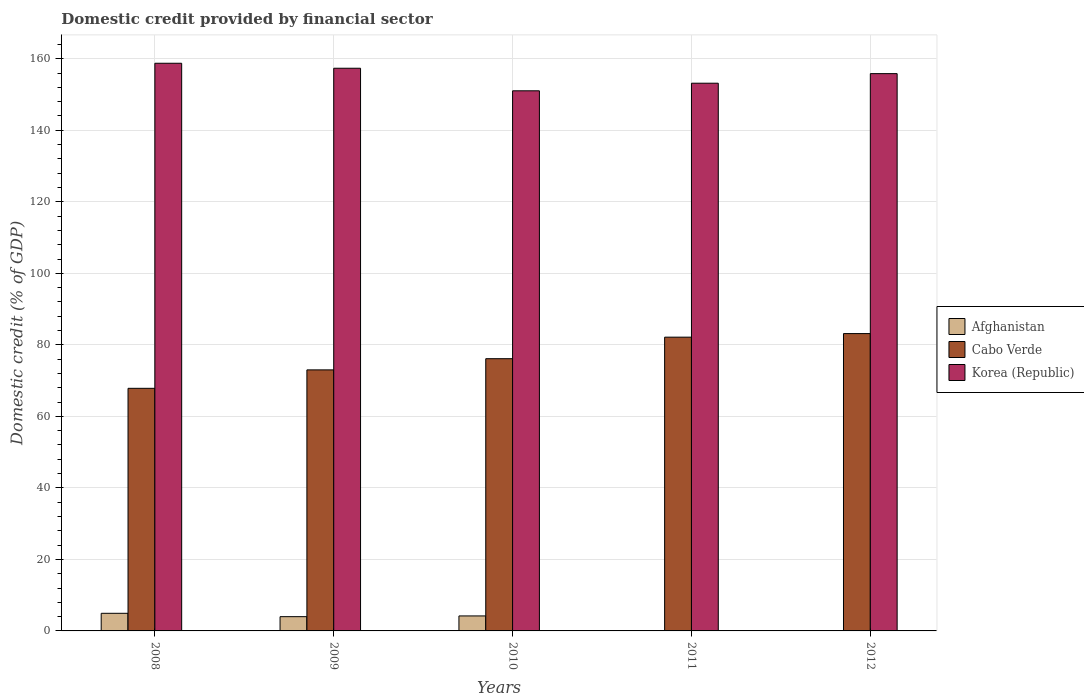How many different coloured bars are there?
Provide a succinct answer. 3. How many groups of bars are there?
Ensure brevity in your answer.  5. Are the number of bars on each tick of the X-axis equal?
Ensure brevity in your answer.  No. How many bars are there on the 3rd tick from the left?
Your response must be concise. 3. How many bars are there on the 5th tick from the right?
Give a very brief answer. 3. What is the label of the 4th group of bars from the left?
Give a very brief answer. 2011. In how many cases, is the number of bars for a given year not equal to the number of legend labels?
Keep it short and to the point. 2. What is the domestic credit in Cabo Verde in 2011?
Your answer should be very brief. 82.15. Across all years, what is the maximum domestic credit in Afghanistan?
Offer a terse response. 4.93. Across all years, what is the minimum domestic credit in Cabo Verde?
Offer a terse response. 67.84. In which year was the domestic credit in Cabo Verde maximum?
Provide a short and direct response. 2012. What is the total domestic credit in Afghanistan in the graph?
Make the answer very short. 13.11. What is the difference between the domestic credit in Afghanistan in 2009 and that in 2010?
Provide a short and direct response. -0.2. What is the difference between the domestic credit in Cabo Verde in 2011 and the domestic credit in Korea (Republic) in 2009?
Ensure brevity in your answer.  -75.2. What is the average domestic credit in Afghanistan per year?
Keep it short and to the point. 2.62. In the year 2010, what is the difference between the domestic credit in Cabo Verde and domestic credit in Korea (Republic)?
Provide a succinct answer. -74.91. What is the ratio of the domestic credit in Cabo Verde in 2009 to that in 2011?
Give a very brief answer. 0.89. Is the domestic credit in Cabo Verde in 2008 less than that in 2009?
Provide a short and direct response. Yes. What is the difference between the highest and the second highest domestic credit in Afghanistan?
Offer a very short reply. 0.73. What is the difference between the highest and the lowest domestic credit in Korea (Republic)?
Provide a succinct answer. 7.7. Are all the bars in the graph horizontal?
Make the answer very short. No. How many years are there in the graph?
Offer a very short reply. 5. Does the graph contain grids?
Offer a very short reply. Yes. How are the legend labels stacked?
Make the answer very short. Vertical. What is the title of the graph?
Provide a succinct answer. Domestic credit provided by financial sector. What is the label or title of the Y-axis?
Offer a terse response. Domestic credit (% of GDP). What is the Domestic credit (% of GDP) in Afghanistan in 2008?
Ensure brevity in your answer.  4.93. What is the Domestic credit (% of GDP) in Cabo Verde in 2008?
Your response must be concise. 67.84. What is the Domestic credit (% of GDP) of Korea (Republic) in 2008?
Provide a succinct answer. 158.75. What is the Domestic credit (% of GDP) of Afghanistan in 2009?
Provide a succinct answer. 3.99. What is the Domestic credit (% of GDP) of Cabo Verde in 2009?
Your answer should be very brief. 73. What is the Domestic credit (% of GDP) in Korea (Republic) in 2009?
Ensure brevity in your answer.  157.35. What is the Domestic credit (% of GDP) in Afghanistan in 2010?
Offer a very short reply. 4.19. What is the Domestic credit (% of GDP) of Cabo Verde in 2010?
Give a very brief answer. 76.13. What is the Domestic credit (% of GDP) in Korea (Republic) in 2010?
Your answer should be compact. 151.04. What is the Domestic credit (% of GDP) in Afghanistan in 2011?
Provide a short and direct response. 0. What is the Domestic credit (% of GDP) of Cabo Verde in 2011?
Provide a succinct answer. 82.15. What is the Domestic credit (% of GDP) of Korea (Republic) in 2011?
Keep it short and to the point. 153.17. What is the Domestic credit (% of GDP) of Afghanistan in 2012?
Provide a short and direct response. 0. What is the Domestic credit (% of GDP) of Cabo Verde in 2012?
Offer a terse response. 83.15. What is the Domestic credit (% of GDP) in Korea (Republic) in 2012?
Your response must be concise. 155.85. Across all years, what is the maximum Domestic credit (% of GDP) of Afghanistan?
Your answer should be very brief. 4.93. Across all years, what is the maximum Domestic credit (% of GDP) of Cabo Verde?
Offer a very short reply. 83.15. Across all years, what is the maximum Domestic credit (% of GDP) in Korea (Republic)?
Your answer should be compact. 158.75. Across all years, what is the minimum Domestic credit (% of GDP) of Cabo Verde?
Offer a very short reply. 67.84. Across all years, what is the minimum Domestic credit (% of GDP) of Korea (Republic)?
Your response must be concise. 151.04. What is the total Domestic credit (% of GDP) of Afghanistan in the graph?
Offer a very short reply. 13.11. What is the total Domestic credit (% of GDP) of Cabo Verde in the graph?
Provide a succinct answer. 382.27. What is the total Domestic credit (% of GDP) of Korea (Republic) in the graph?
Ensure brevity in your answer.  776.15. What is the difference between the Domestic credit (% of GDP) in Afghanistan in 2008 and that in 2009?
Give a very brief answer. 0.94. What is the difference between the Domestic credit (% of GDP) of Cabo Verde in 2008 and that in 2009?
Your response must be concise. -5.16. What is the difference between the Domestic credit (% of GDP) of Korea (Republic) in 2008 and that in 2009?
Your answer should be compact. 1.39. What is the difference between the Domestic credit (% of GDP) of Afghanistan in 2008 and that in 2010?
Offer a very short reply. 0.73. What is the difference between the Domestic credit (% of GDP) of Cabo Verde in 2008 and that in 2010?
Ensure brevity in your answer.  -8.29. What is the difference between the Domestic credit (% of GDP) in Korea (Republic) in 2008 and that in 2010?
Give a very brief answer. 7.7. What is the difference between the Domestic credit (% of GDP) in Cabo Verde in 2008 and that in 2011?
Your response must be concise. -14.31. What is the difference between the Domestic credit (% of GDP) in Korea (Republic) in 2008 and that in 2011?
Offer a terse response. 5.58. What is the difference between the Domestic credit (% of GDP) in Cabo Verde in 2008 and that in 2012?
Your answer should be very brief. -15.31. What is the difference between the Domestic credit (% of GDP) in Korea (Republic) in 2008 and that in 2012?
Offer a terse response. 2.9. What is the difference between the Domestic credit (% of GDP) in Afghanistan in 2009 and that in 2010?
Provide a succinct answer. -0.2. What is the difference between the Domestic credit (% of GDP) of Cabo Verde in 2009 and that in 2010?
Provide a succinct answer. -3.13. What is the difference between the Domestic credit (% of GDP) of Korea (Republic) in 2009 and that in 2010?
Ensure brevity in your answer.  6.31. What is the difference between the Domestic credit (% of GDP) in Cabo Verde in 2009 and that in 2011?
Offer a very short reply. -9.15. What is the difference between the Domestic credit (% of GDP) of Korea (Republic) in 2009 and that in 2011?
Your answer should be compact. 4.19. What is the difference between the Domestic credit (% of GDP) in Cabo Verde in 2009 and that in 2012?
Ensure brevity in your answer.  -10.15. What is the difference between the Domestic credit (% of GDP) in Korea (Republic) in 2009 and that in 2012?
Keep it short and to the point. 1.51. What is the difference between the Domestic credit (% of GDP) of Cabo Verde in 2010 and that in 2011?
Make the answer very short. -6.02. What is the difference between the Domestic credit (% of GDP) of Korea (Republic) in 2010 and that in 2011?
Provide a short and direct response. -2.12. What is the difference between the Domestic credit (% of GDP) of Cabo Verde in 2010 and that in 2012?
Give a very brief answer. -7.02. What is the difference between the Domestic credit (% of GDP) in Korea (Republic) in 2010 and that in 2012?
Make the answer very short. -4.8. What is the difference between the Domestic credit (% of GDP) of Cabo Verde in 2011 and that in 2012?
Give a very brief answer. -1. What is the difference between the Domestic credit (% of GDP) in Korea (Republic) in 2011 and that in 2012?
Your response must be concise. -2.68. What is the difference between the Domestic credit (% of GDP) of Afghanistan in 2008 and the Domestic credit (% of GDP) of Cabo Verde in 2009?
Offer a very short reply. -68.08. What is the difference between the Domestic credit (% of GDP) of Afghanistan in 2008 and the Domestic credit (% of GDP) of Korea (Republic) in 2009?
Offer a very short reply. -152.43. What is the difference between the Domestic credit (% of GDP) in Cabo Verde in 2008 and the Domestic credit (% of GDP) in Korea (Republic) in 2009?
Make the answer very short. -89.51. What is the difference between the Domestic credit (% of GDP) in Afghanistan in 2008 and the Domestic credit (% of GDP) in Cabo Verde in 2010?
Make the answer very short. -71.2. What is the difference between the Domestic credit (% of GDP) in Afghanistan in 2008 and the Domestic credit (% of GDP) in Korea (Republic) in 2010?
Ensure brevity in your answer.  -146.12. What is the difference between the Domestic credit (% of GDP) of Cabo Verde in 2008 and the Domestic credit (% of GDP) of Korea (Republic) in 2010?
Provide a short and direct response. -83.2. What is the difference between the Domestic credit (% of GDP) in Afghanistan in 2008 and the Domestic credit (% of GDP) in Cabo Verde in 2011?
Ensure brevity in your answer.  -77.22. What is the difference between the Domestic credit (% of GDP) in Afghanistan in 2008 and the Domestic credit (% of GDP) in Korea (Republic) in 2011?
Make the answer very short. -148.24. What is the difference between the Domestic credit (% of GDP) in Cabo Verde in 2008 and the Domestic credit (% of GDP) in Korea (Republic) in 2011?
Provide a succinct answer. -85.32. What is the difference between the Domestic credit (% of GDP) of Afghanistan in 2008 and the Domestic credit (% of GDP) of Cabo Verde in 2012?
Your response must be concise. -78.23. What is the difference between the Domestic credit (% of GDP) of Afghanistan in 2008 and the Domestic credit (% of GDP) of Korea (Republic) in 2012?
Your answer should be compact. -150.92. What is the difference between the Domestic credit (% of GDP) in Cabo Verde in 2008 and the Domestic credit (% of GDP) in Korea (Republic) in 2012?
Ensure brevity in your answer.  -88. What is the difference between the Domestic credit (% of GDP) in Afghanistan in 2009 and the Domestic credit (% of GDP) in Cabo Verde in 2010?
Your response must be concise. -72.14. What is the difference between the Domestic credit (% of GDP) of Afghanistan in 2009 and the Domestic credit (% of GDP) of Korea (Republic) in 2010?
Provide a short and direct response. -147.05. What is the difference between the Domestic credit (% of GDP) of Cabo Verde in 2009 and the Domestic credit (% of GDP) of Korea (Republic) in 2010?
Your response must be concise. -78.04. What is the difference between the Domestic credit (% of GDP) in Afghanistan in 2009 and the Domestic credit (% of GDP) in Cabo Verde in 2011?
Keep it short and to the point. -78.16. What is the difference between the Domestic credit (% of GDP) in Afghanistan in 2009 and the Domestic credit (% of GDP) in Korea (Republic) in 2011?
Your response must be concise. -149.18. What is the difference between the Domestic credit (% of GDP) in Cabo Verde in 2009 and the Domestic credit (% of GDP) in Korea (Republic) in 2011?
Provide a short and direct response. -80.16. What is the difference between the Domestic credit (% of GDP) in Afghanistan in 2009 and the Domestic credit (% of GDP) in Cabo Verde in 2012?
Make the answer very short. -79.16. What is the difference between the Domestic credit (% of GDP) of Afghanistan in 2009 and the Domestic credit (% of GDP) of Korea (Republic) in 2012?
Your answer should be compact. -151.86. What is the difference between the Domestic credit (% of GDP) of Cabo Verde in 2009 and the Domestic credit (% of GDP) of Korea (Republic) in 2012?
Ensure brevity in your answer.  -82.84. What is the difference between the Domestic credit (% of GDP) of Afghanistan in 2010 and the Domestic credit (% of GDP) of Cabo Verde in 2011?
Keep it short and to the point. -77.96. What is the difference between the Domestic credit (% of GDP) in Afghanistan in 2010 and the Domestic credit (% of GDP) in Korea (Republic) in 2011?
Offer a terse response. -148.97. What is the difference between the Domestic credit (% of GDP) of Cabo Verde in 2010 and the Domestic credit (% of GDP) of Korea (Republic) in 2011?
Make the answer very short. -77.04. What is the difference between the Domestic credit (% of GDP) of Afghanistan in 2010 and the Domestic credit (% of GDP) of Cabo Verde in 2012?
Your answer should be very brief. -78.96. What is the difference between the Domestic credit (% of GDP) of Afghanistan in 2010 and the Domestic credit (% of GDP) of Korea (Republic) in 2012?
Keep it short and to the point. -151.65. What is the difference between the Domestic credit (% of GDP) of Cabo Verde in 2010 and the Domestic credit (% of GDP) of Korea (Republic) in 2012?
Offer a very short reply. -79.72. What is the difference between the Domestic credit (% of GDP) in Cabo Verde in 2011 and the Domestic credit (% of GDP) in Korea (Republic) in 2012?
Provide a short and direct response. -73.7. What is the average Domestic credit (% of GDP) in Afghanistan per year?
Your answer should be very brief. 2.62. What is the average Domestic credit (% of GDP) in Cabo Verde per year?
Your response must be concise. 76.45. What is the average Domestic credit (% of GDP) in Korea (Republic) per year?
Your answer should be compact. 155.23. In the year 2008, what is the difference between the Domestic credit (% of GDP) of Afghanistan and Domestic credit (% of GDP) of Cabo Verde?
Keep it short and to the point. -62.92. In the year 2008, what is the difference between the Domestic credit (% of GDP) of Afghanistan and Domestic credit (% of GDP) of Korea (Republic)?
Offer a terse response. -153.82. In the year 2008, what is the difference between the Domestic credit (% of GDP) of Cabo Verde and Domestic credit (% of GDP) of Korea (Republic)?
Provide a succinct answer. -90.9. In the year 2009, what is the difference between the Domestic credit (% of GDP) of Afghanistan and Domestic credit (% of GDP) of Cabo Verde?
Offer a terse response. -69.01. In the year 2009, what is the difference between the Domestic credit (% of GDP) of Afghanistan and Domestic credit (% of GDP) of Korea (Republic)?
Offer a terse response. -153.36. In the year 2009, what is the difference between the Domestic credit (% of GDP) in Cabo Verde and Domestic credit (% of GDP) in Korea (Republic)?
Keep it short and to the point. -84.35. In the year 2010, what is the difference between the Domestic credit (% of GDP) of Afghanistan and Domestic credit (% of GDP) of Cabo Verde?
Give a very brief answer. -71.94. In the year 2010, what is the difference between the Domestic credit (% of GDP) in Afghanistan and Domestic credit (% of GDP) in Korea (Republic)?
Your answer should be compact. -146.85. In the year 2010, what is the difference between the Domestic credit (% of GDP) in Cabo Verde and Domestic credit (% of GDP) in Korea (Republic)?
Ensure brevity in your answer.  -74.91. In the year 2011, what is the difference between the Domestic credit (% of GDP) in Cabo Verde and Domestic credit (% of GDP) in Korea (Republic)?
Ensure brevity in your answer.  -71.02. In the year 2012, what is the difference between the Domestic credit (% of GDP) of Cabo Verde and Domestic credit (% of GDP) of Korea (Republic)?
Provide a short and direct response. -72.69. What is the ratio of the Domestic credit (% of GDP) in Afghanistan in 2008 to that in 2009?
Provide a short and direct response. 1.23. What is the ratio of the Domestic credit (% of GDP) in Cabo Verde in 2008 to that in 2009?
Offer a very short reply. 0.93. What is the ratio of the Domestic credit (% of GDP) in Korea (Republic) in 2008 to that in 2009?
Your answer should be very brief. 1.01. What is the ratio of the Domestic credit (% of GDP) in Afghanistan in 2008 to that in 2010?
Ensure brevity in your answer.  1.18. What is the ratio of the Domestic credit (% of GDP) in Cabo Verde in 2008 to that in 2010?
Ensure brevity in your answer.  0.89. What is the ratio of the Domestic credit (% of GDP) of Korea (Republic) in 2008 to that in 2010?
Offer a very short reply. 1.05. What is the ratio of the Domestic credit (% of GDP) of Cabo Verde in 2008 to that in 2011?
Give a very brief answer. 0.83. What is the ratio of the Domestic credit (% of GDP) in Korea (Republic) in 2008 to that in 2011?
Provide a short and direct response. 1.04. What is the ratio of the Domestic credit (% of GDP) of Cabo Verde in 2008 to that in 2012?
Your response must be concise. 0.82. What is the ratio of the Domestic credit (% of GDP) in Korea (Republic) in 2008 to that in 2012?
Your answer should be compact. 1.02. What is the ratio of the Domestic credit (% of GDP) in Afghanistan in 2009 to that in 2010?
Make the answer very short. 0.95. What is the ratio of the Domestic credit (% of GDP) of Cabo Verde in 2009 to that in 2010?
Give a very brief answer. 0.96. What is the ratio of the Domestic credit (% of GDP) of Korea (Republic) in 2009 to that in 2010?
Give a very brief answer. 1.04. What is the ratio of the Domestic credit (% of GDP) in Cabo Verde in 2009 to that in 2011?
Your response must be concise. 0.89. What is the ratio of the Domestic credit (% of GDP) of Korea (Republic) in 2009 to that in 2011?
Your answer should be compact. 1.03. What is the ratio of the Domestic credit (% of GDP) of Cabo Verde in 2009 to that in 2012?
Provide a succinct answer. 0.88. What is the ratio of the Domestic credit (% of GDP) in Korea (Republic) in 2009 to that in 2012?
Offer a terse response. 1.01. What is the ratio of the Domestic credit (% of GDP) in Cabo Verde in 2010 to that in 2011?
Keep it short and to the point. 0.93. What is the ratio of the Domestic credit (% of GDP) of Korea (Republic) in 2010 to that in 2011?
Offer a very short reply. 0.99. What is the ratio of the Domestic credit (% of GDP) of Cabo Verde in 2010 to that in 2012?
Give a very brief answer. 0.92. What is the ratio of the Domestic credit (% of GDP) in Korea (Republic) in 2010 to that in 2012?
Provide a succinct answer. 0.97. What is the ratio of the Domestic credit (% of GDP) of Cabo Verde in 2011 to that in 2012?
Your response must be concise. 0.99. What is the ratio of the Domestic credit (% of GDP) of Korea (Republic) in 2011 to that in 2012?
Provide a short and direct response. 0.98. What is the difference between the highest and the second highest Domestic credit (% of GDP) in Afghanistan?
Your answer should be compact. 0.73. What is the difference between the highest and the second highest Domestic credit (% of GDP) in Cabo Verde?
Provide a short and direct response. 1. What is the difference between the highest and the second highest Domestic credit (% of GDP) of Korea (Republic)?
Provide a short and direct response. 1.39. What is the difference between the highest and the lowest Domestic credit (% of GDP) in Afghanistan?
Your answer should be very brief. 4.93. What is the difference between the highest and the lowest Domestic credit (% of GDP) of Cabo Verde?
Offer a very short reply. 15.31. What is the difference between the highest and the lowest Domestic credit (% of GDP) of Korea (Republic)?
Make the answer very short. 7.7. 